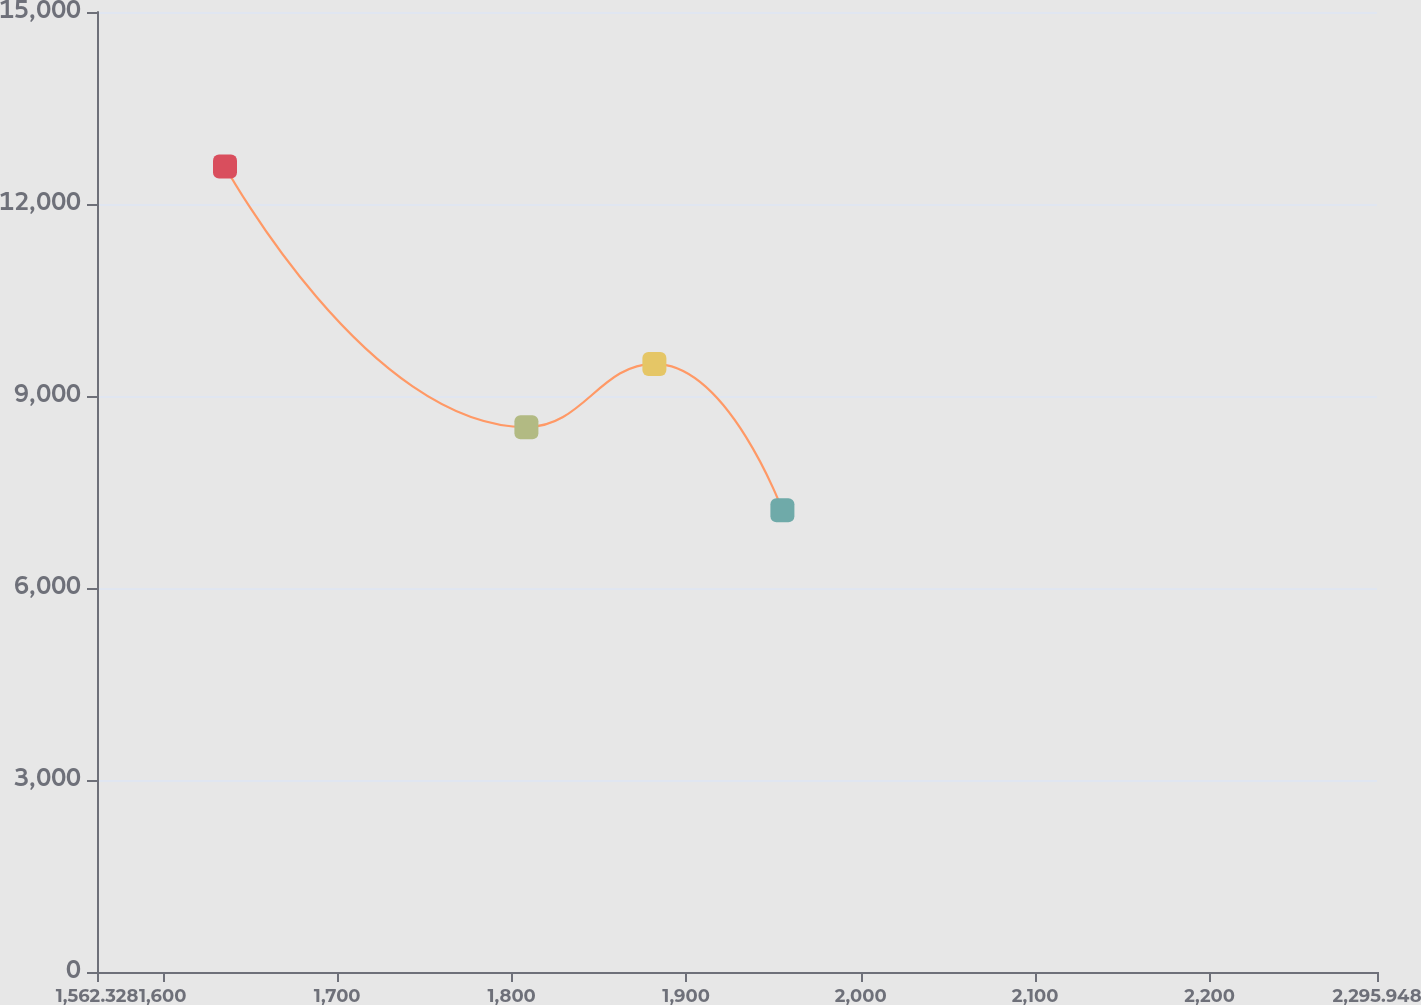Convert chart to OTSL. <chart><loc_0><loc_0><loc_500><loc_500><line_chart><ecel><fcel>(in thousands)<nl><fcel>1635.69<fcel>12586.6<nl><fcel>1808.44<fcel>8513.1<nl><fcel>1881.8<fcel>9501.82<nl><fcel>1955.16<fcel>7215.14<nl><fcel>2369.31<fcel>6618.31<nl></chart> 